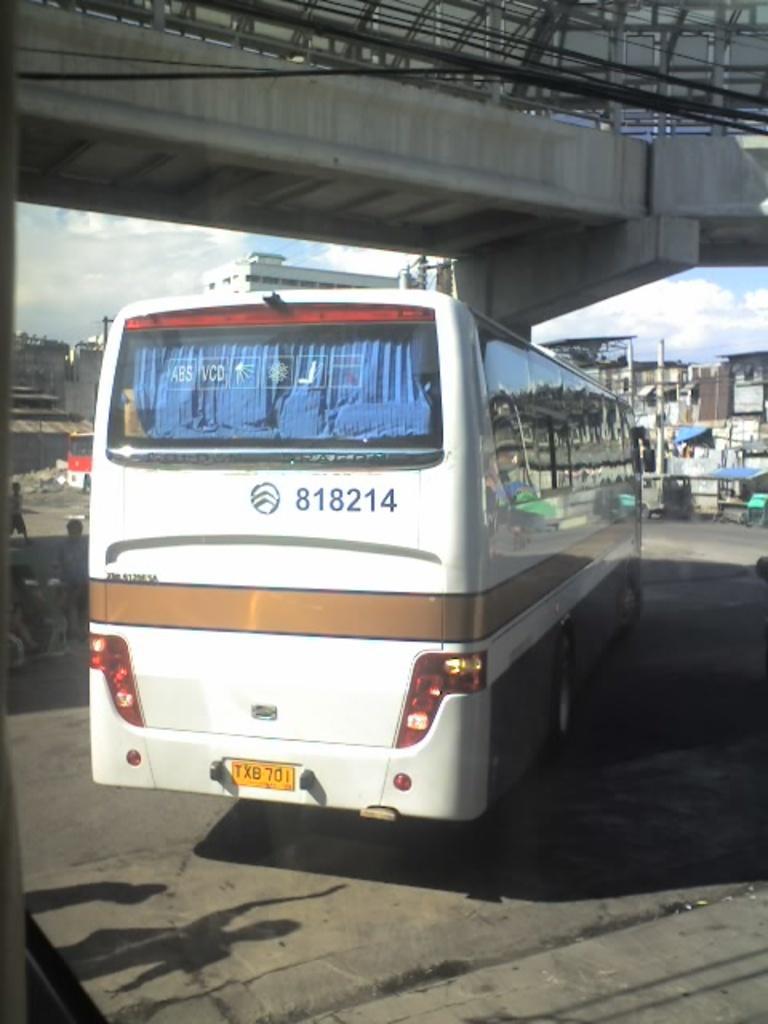How would you summarize this image in a sentence or two? In this picture we can see a bus and bridge, beside to the bus we can find few people, in the background we can see few buildings and poles. 